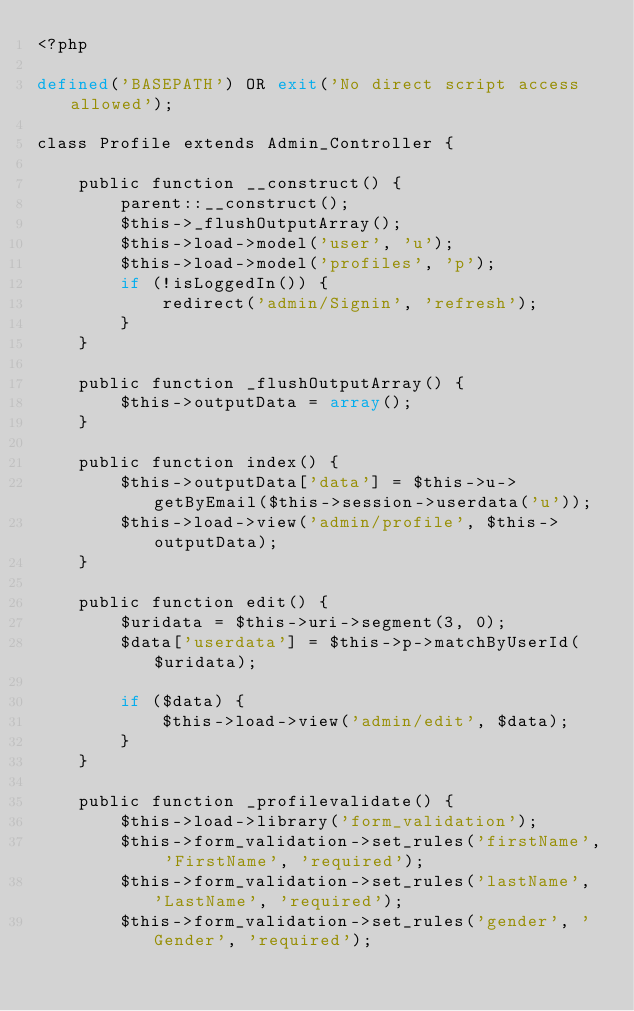<code> <loc_0><loc_0><loc_500><loc_500><_PHP_><?php

defined('BASEPATH') OR exit('No direct script access allowed');

class Profile extends Admin_Controller {

    public function __construct() {
        parent::__construct();
        $this->_flushOutputArray();
        $this->load->model('user', 'u');
        $this->load->model('profiles', 'p');
        if (!isLoggedIn()) {
            redirect('admin/Signin', 'refresh');
        }
    }

    public function _flushOutputArray() {
        $this->outputData = array();
    }

    public function index() {
        $this->outputData['data'] = $this->u->getByEmail($this->session->userdata('u'));
        $this->load->view('admin/profile', $this->outputData);
    }

    public function edit() {
        $uridata = $this->uri->segment(3, 0);
        $data['userdata'] = $this->p->matchByUserId($uridata);

        if ($data) {
            $this->load->view('admin/edit', $data);
        }
    }

    public function _profilevalidate() {
        $this->load->library('form_validation');
        $this->form_validation->set_rules('firstName', 'FirstName', 'required');
        $this->form_validation->set_rules('lastName', 'LastName', 'required');
        $this->form_validation->set_rules('gender', 'Gender', 'required');</code> 